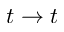<formula> <loc_0><loc_0><loc_500><loc_500>t \rightarrow t</formula> 